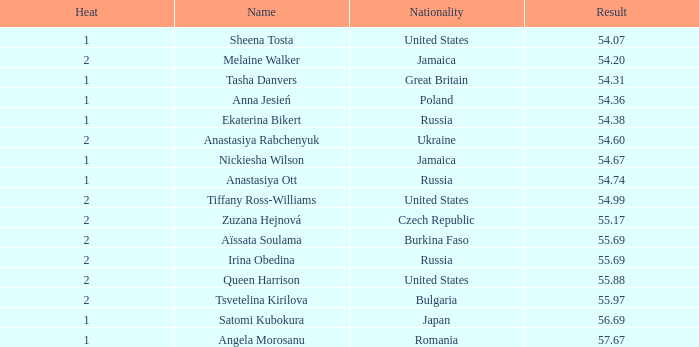Who obtained a result of 5 Nickiesha Wilson. 